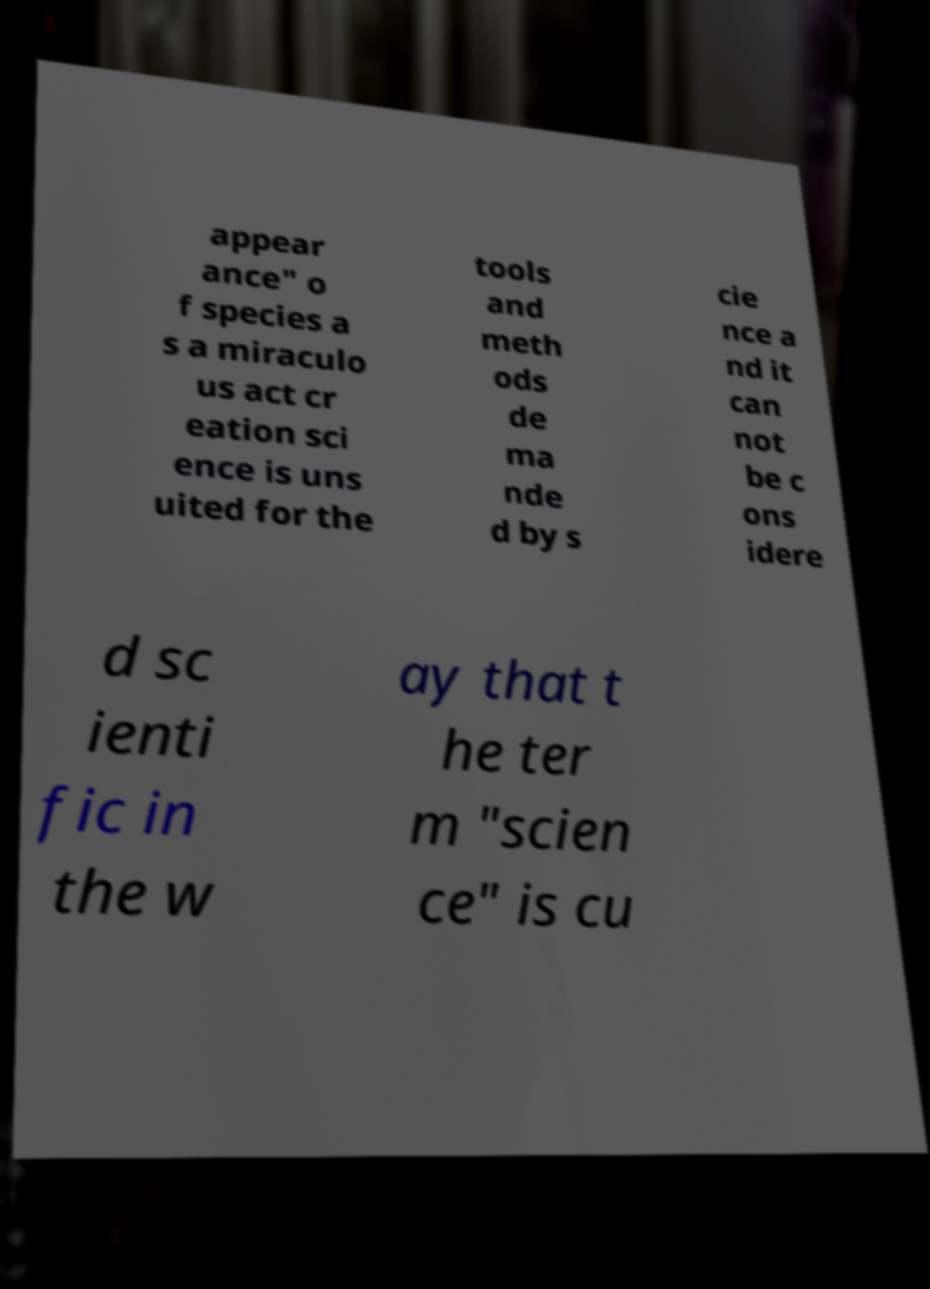Could you extract and type out the text from this image? appear ance" o f species a s a miraculo us act cr eation sci ence is uns uited for the tools and meth ods de ma nde d by s cie nce a nd it can not be c ons idere d sc ienti fic in the w ay that t he ter m "scien ce" is cu 